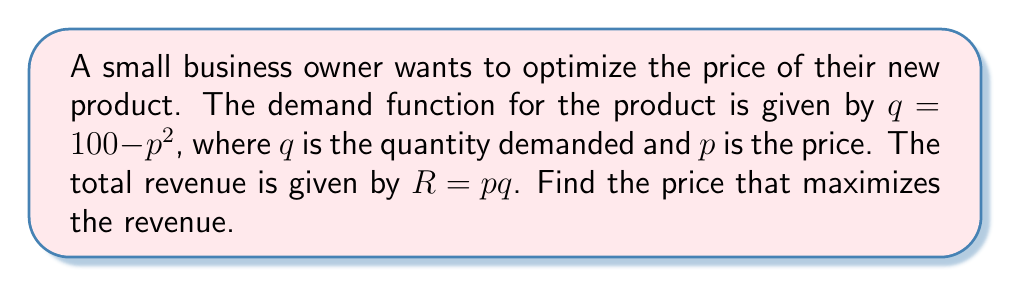Can you solve this math problem? Let's approach this step-by-step:

1) The revenue function is $R = pq = p(100 - p^2)$
   
   $R = 100p - p^3$

2) To find the maximum revenue, we need to find where the derivative of R with respect to p is zero:

   $\frac{dR}{dp} = 100 - 3p^2$

3) Set this equal to zero:

   $100 - 3p^2 = 0$

4) Rearrange to standard form:

   $3p^2 - 100 = 0$

5) Divide by 3:

   $p^2 - \frac{100}{3} = 0$

6) This is a quadratic equation. We can solve it using the quadratic formula:

   $p = \pm \sqrt{\frac{100}{3}}$

7) Since price can't be negative, we only consider the positive root:

   $p = \sqrt{\frac{100}{3}} \approx 5.77$

8) To verify this is a maximum (not a minimum), we can check that the second derivative is negative:

   $\frac{d^2R}{dp^2} = -6p$, which is negative when $p$ is positive.

Therefore, the revenue is maximized when the price is approximately $5.77.
Answer: $p = \sqrt{\frac{100}{3}} \approx 5.77$ 